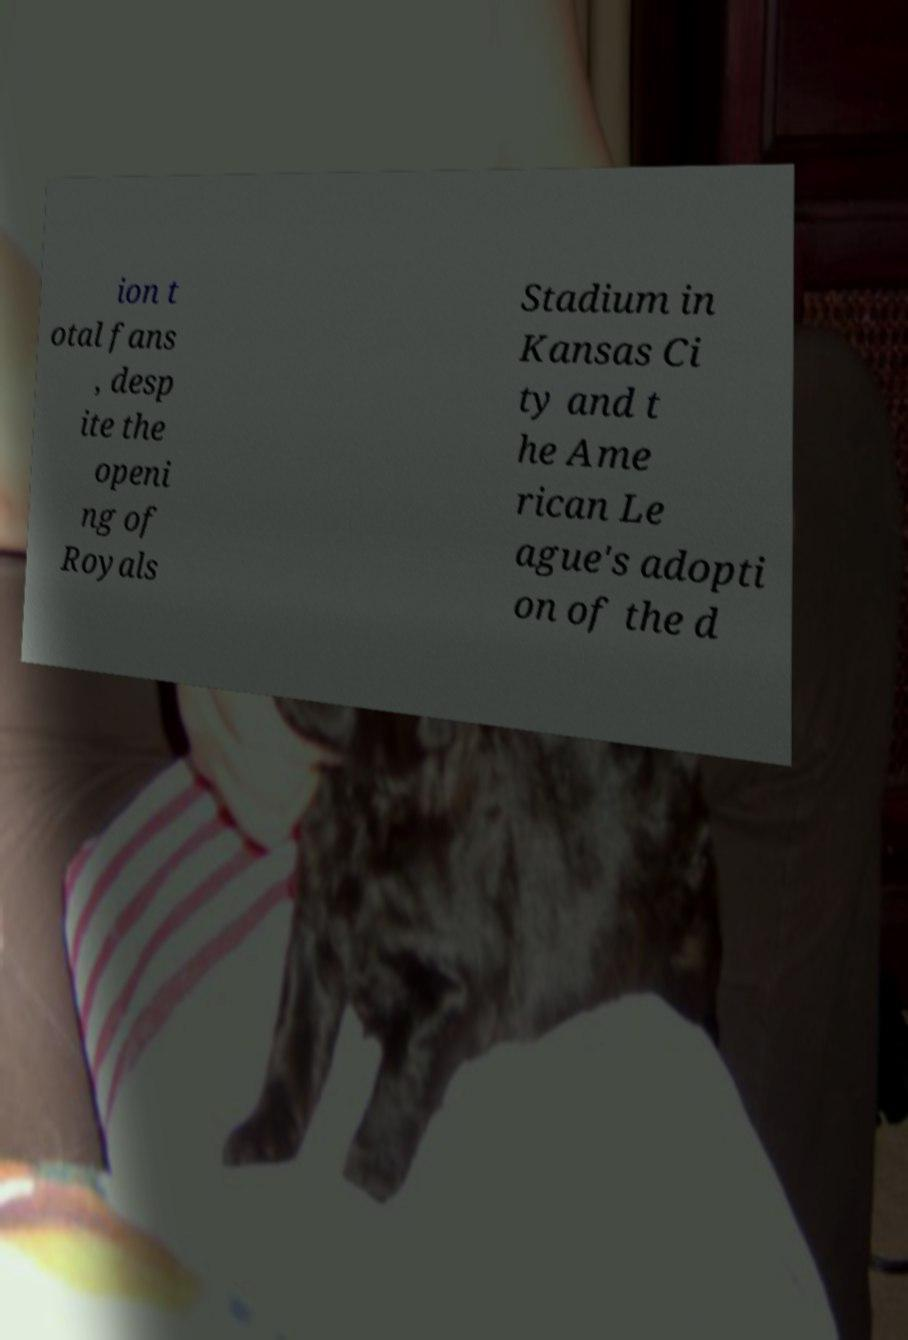Could you extract and type out the text from this image? ion t otal fans , desp ite the openi ng of Royals Stadium in Kansas Ci ty and t he Ame rican Le ague's adopti on of the d 